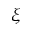Convert formula to latex. <formula><loc_0><loc_0><loc_500><loc_500>\xi</formula> 